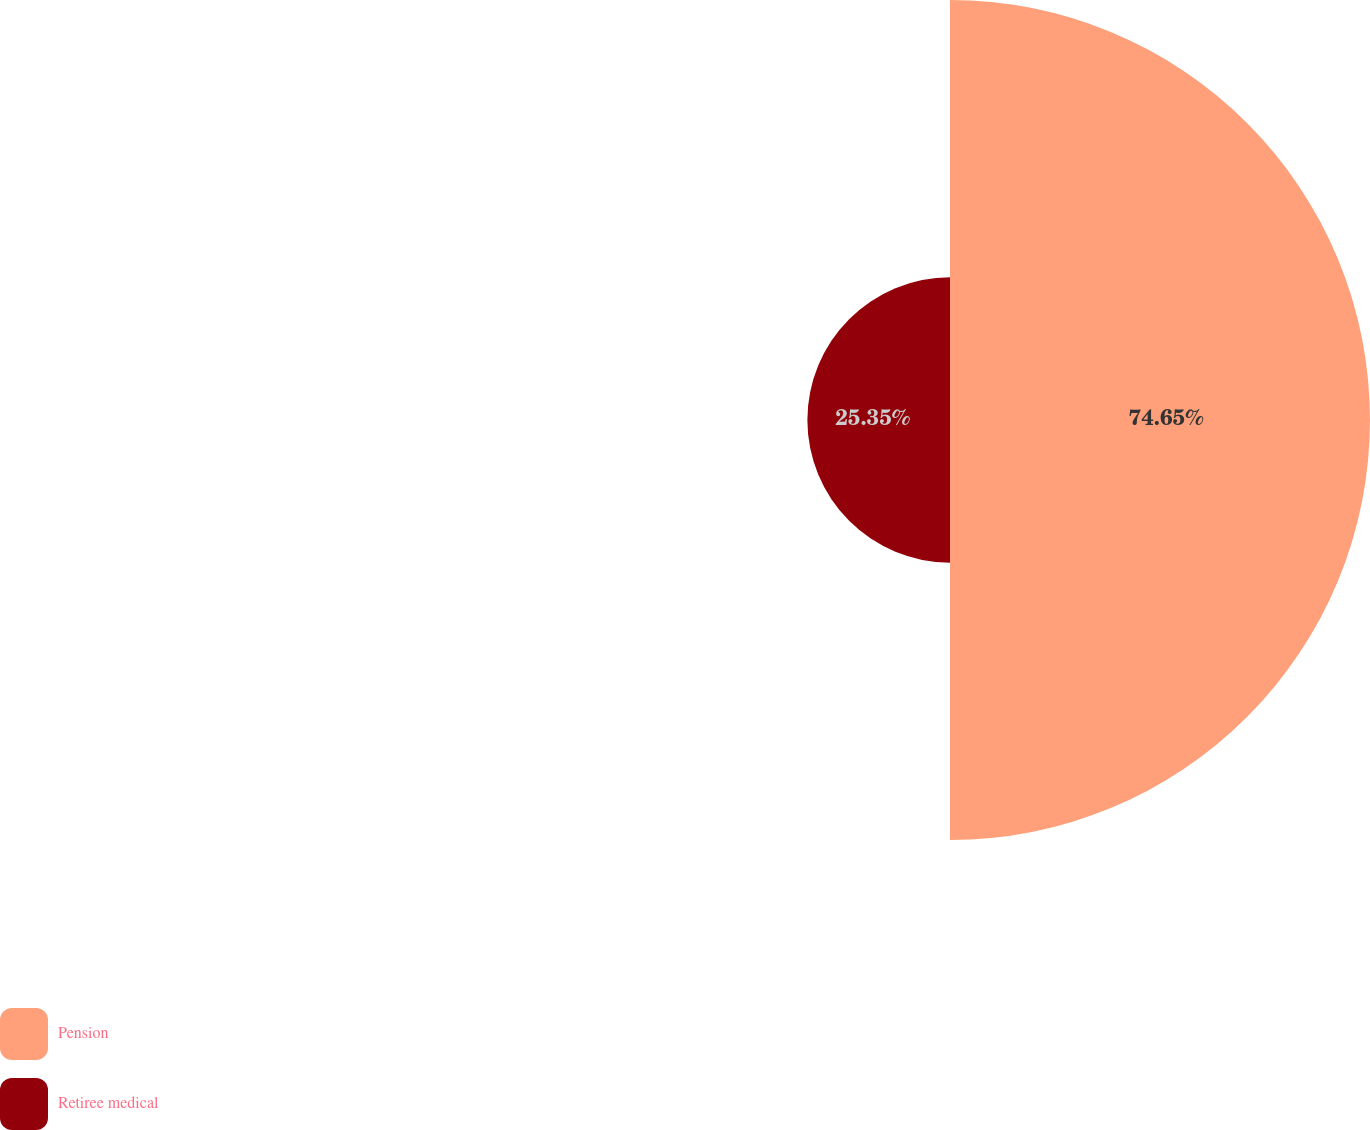Convert chart. <chart><loc_0><loc_0><loc_500><loc_500><pie_chart><fcel>Pension<fcel>Retiree medical<nl><fcel>74.65%<fcel>25.35%<nl></chart> 